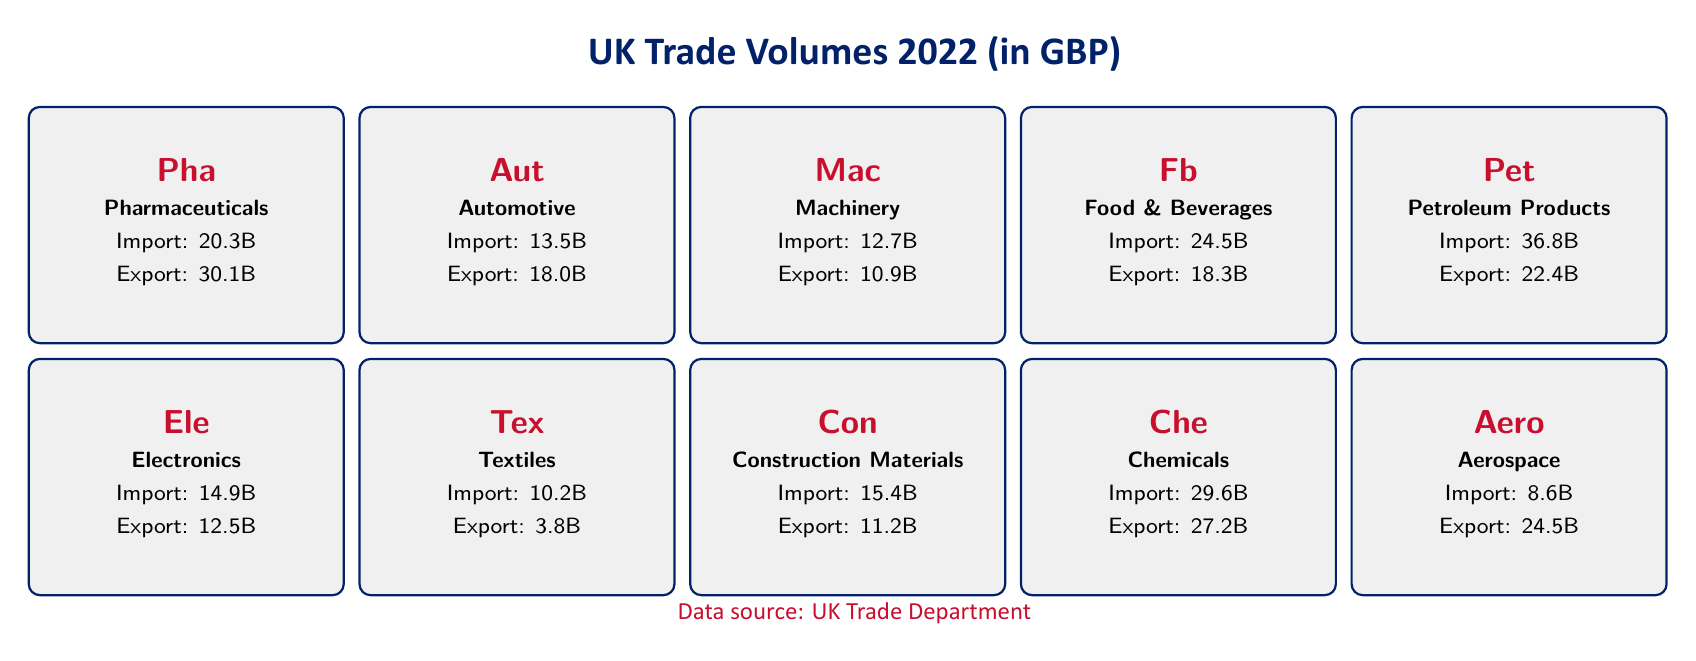What is the export volume of Pharmaceuticals? The table shows that the export volume for Pharmaceuticals is listed as 30.1 billion GBP.
Answer: 30.1 billion GBP Which industry has the highest net trade? By comparing the Net Trade values across all industries, Aerospace has the highest net trade at 15.9 billion GBP.
Answer: Aerospace What is the total import volume of Automotive and Electronics combined? The total import volume can be found by adding the import volumes of Automotive (13.5 billion GBP) and Electronics (14.9 billion GBP). So, 13.5 + 14.9 = 28.4 billion GBP.
Answer: 28.4 billion GBP Is the net trade for Food and Beverages positive? The net trade for Food and Beverages is -6.2 billion GBP, indicating that it is not positive.
Answer: No What is the difference between the export and import volumes of Petroleum Products? To find this difference, we subtract the import volume (36.8 billion GBP) from the export volume (22.4 billion GBP). The calculation is 22.4 - 36.8 = -14.4 billion GBP.
Answer: -14.4 billion GBP Which industry has the smallest export volume? Looking through the export volumes, Textiles has the smallest export volume of 3.8 billion GBP.
Answer: Textiles What is the average import volume of the industries listed? To calculate the average, we first sum up the import volumes: 20.3 + 13.5 + 12.7 + 24.5 + 36.8 + 14.9 + 10.2 + 15.4 + 29.6 + 8.6 =  164.5 billion GBP. Then, we divide this by the number of industries (10): 164.5 / 10 = 16.45 billion GBP.
Answer: 16.45 billion GBP Do both Chemicals and Machinery have a negative net trade? The net trade for Chemicals is -2.4 billion GBP and for Machinery it is -1.8 billion GBP; therefore, both have negative net trades.
Answer: Yes Which industry has the lowest net trade value? By examining the Net Trade values, Petroleum Products has the lowest at -14.4 billion GBP.
Answer: Petroleum Products 